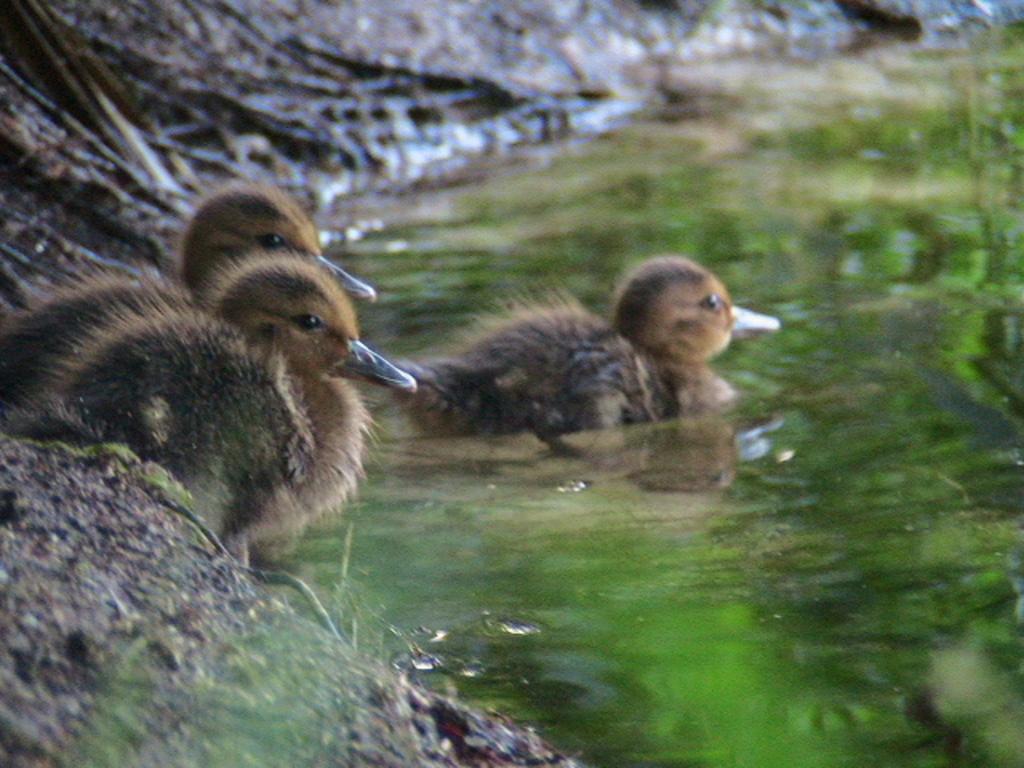Please provide a concise description of this image. Here in this picture we can see water present over a place and in that we can see a mallard present and behind that on the ground we can see another couple of mallards present. 